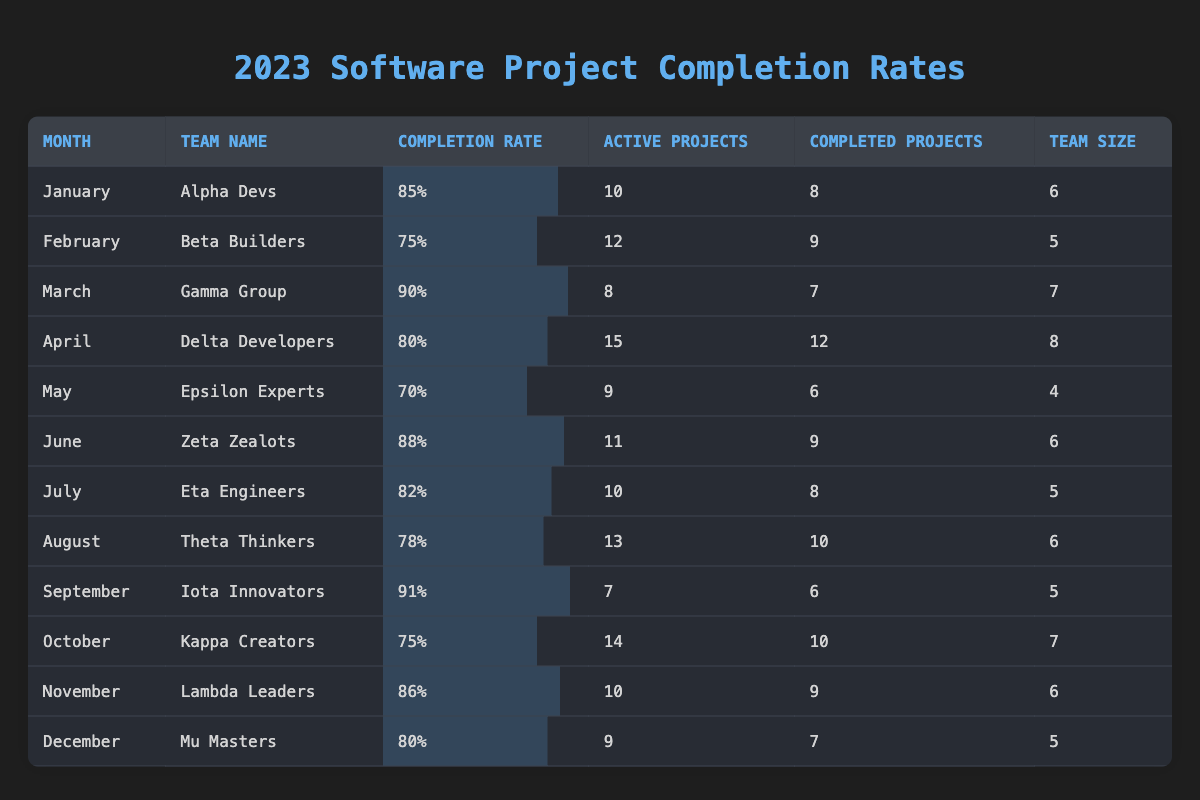What is the project completion rate for March? From the table, the project completion rate for March is listed as 90% under the team Gamma Group.
Answer: 90% Which team had the highest project completion rate? By reviewing the table, the maximum completion rate is 91%, which belongs to the Iota Innovators for September.
Answer: Iota Innovators How many completed projects did Delta Developers have? The table indicates that Delta Developers completed 12 projects in April.
Answer: 12 What is the average project completion rate for the first quarter (January to March)? To find the average, sum the rates: (85 + 75 + 90) = 250. There are 3 months in the first quarter, so the average is 250 / 3 = approximately 83.33.
Answer: 83.33 Did Epsilon Experts complete more projects than they had active in May? Epsilon Experts had 6 completed projects and 9 active projects in May, therefore they completed fewer projects than their active count.
Answer: No Which month did Team Kappa Creators complete the fewest projects relative to their active projects? Kappa Creators completed 10 projects out of 14 active projects in October, which yields a completion rate of 71.4%. Comparing this to other months, this is the lowest relative project completion for the active projects they have.
Answer: October How many total completed projects were there across all teams in the year? Adding all the completed projects from each team results in: 8 + 9 + 7 + 12 + 6 + 9 + 8 + 10 + 6 + 10 + 9 + 7 = 8 + 9 + 7 + 12 + 6 + 9 + 8 + 10 + 6 + 10 + 9 + 7 = 9 + 10 + 9 + 7 = 79.
Answer: 79 Did any team maintain an 80% or better completion rate for all months they were active? Looking closely at the table, we find that teams Alpha Devs, Gamma Group, Zeta Zealots, and Lambda Leaders all maintained an 80% or better completion rate across their active periods.
Answer: Yes What is the total number of projects that the Theta Thinkers had active in August? The table shows that Theta Thinkers had 13 active projects in August.
Answer: 13 Which team had the smallest team size during the year? The data indicates that Epsilon Experts had the smallest team size with 4 members in May, as per the count listed.
Answer: Epsilon Experts 